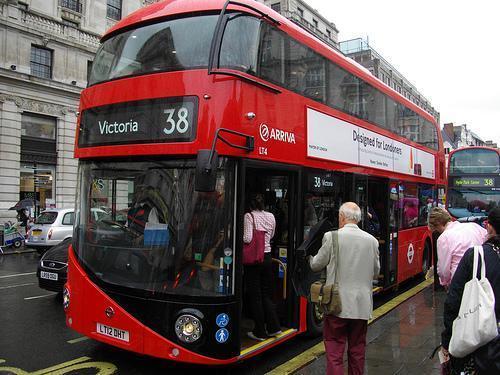How many levels does the bus have?
Give a very brief answer. 2. How many people are waiting to get on the bus?
Give a very brief answer. 4. 